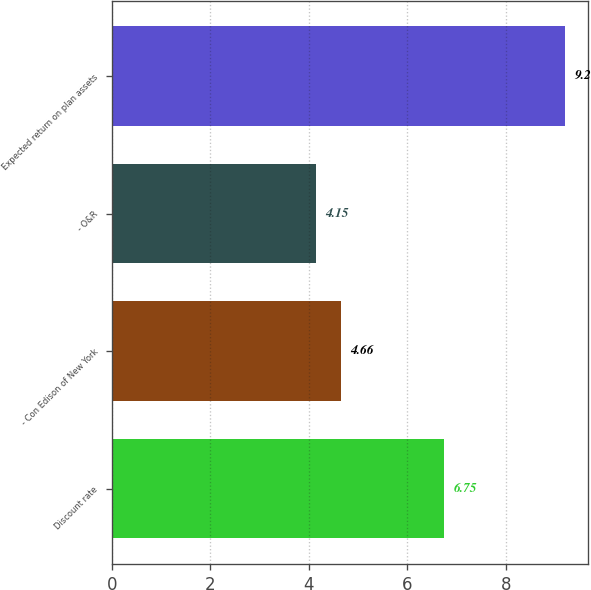<chart> <loc_0><loc_0><loc_500><loc_500><bar_chart><fcel>Discount rate<fcel>- Con Edison of New York<fcel>- O&R<fcel>Expected return on plan assets<nl><fcel>6.75<fcel>4.66<fcel>4.15<fcel>9.2<nl></chart> 